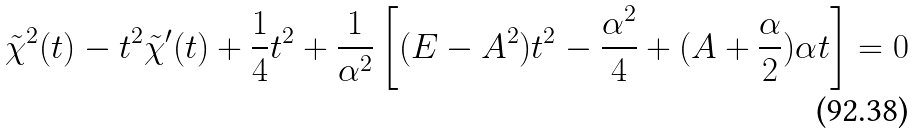Convert formula to latex. <formula><loc_0><loc_0><loc_500><loc_500>\tilde { \chi } ^ { 2 } ( t ) - t ^ { 2 } \tilde { \chi } ^ { \prime } ( t ) + \frac { 1 } { 4 } t ^ { 2 } + \frac { 1 } { \alpha ^ { 2 } } \left [ ( E - A ^ { 2 } ) t ^ { 2 } - \frac { \alpha ^ { 2 } } { 4 } + ( A + \frac { \alpha } { 2 } ) \alpha t \right ] = 0</formula> 